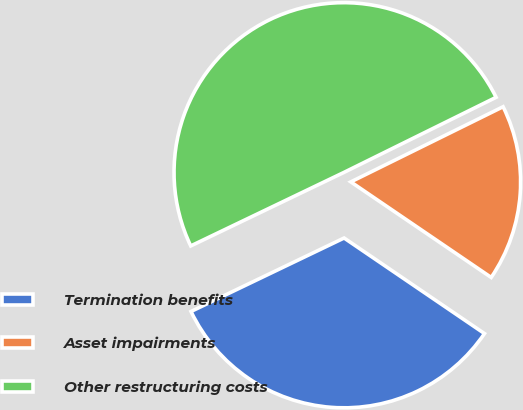Convert chart. <chart><loc_0><loc_0><loc_500><loc_500><pie_chart><fcel>Termination benefits<fcel>Asset impairments<fcel>Other restructuring costs<nl><fcel>33.37%<fcel>16.81%<fcel>49.83%<nl></chart> 